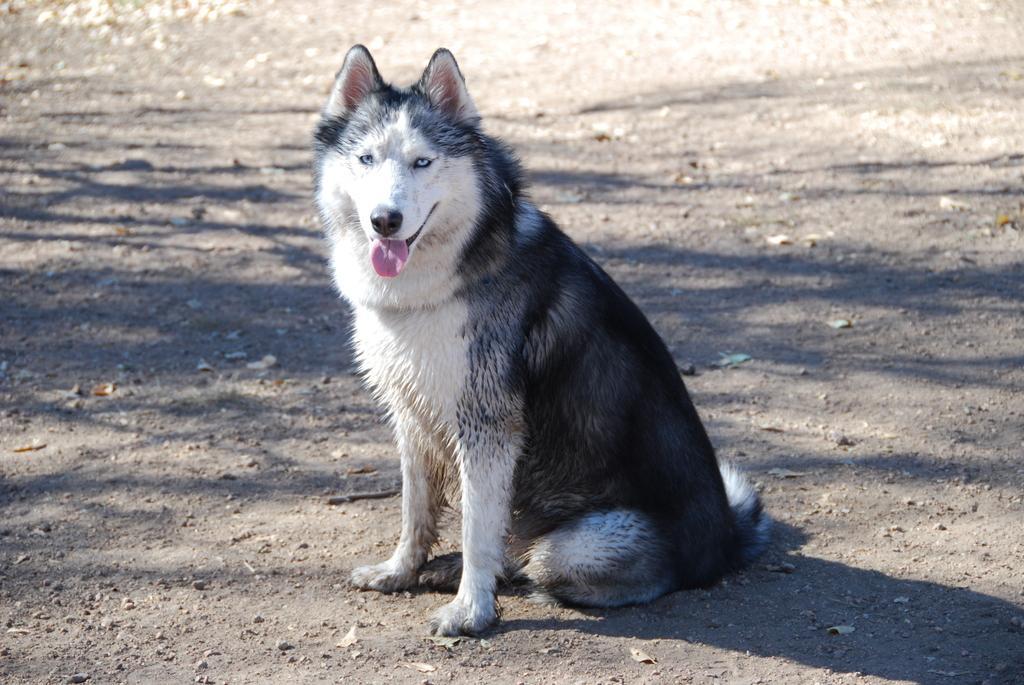Please provide a concise description of this image. In this image we can see a dog sitting on the ground. 